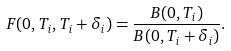<formula> <loc_0><loc_0><loc_500><loc_500>F ( 0 , T _ { i } , T _ { i } + \delta _ { i } ) = \frac { B ( 0 , T _ { i } ) } { B ( 0 , T _ { i } + \delta _ { i } ) } .</formula> 